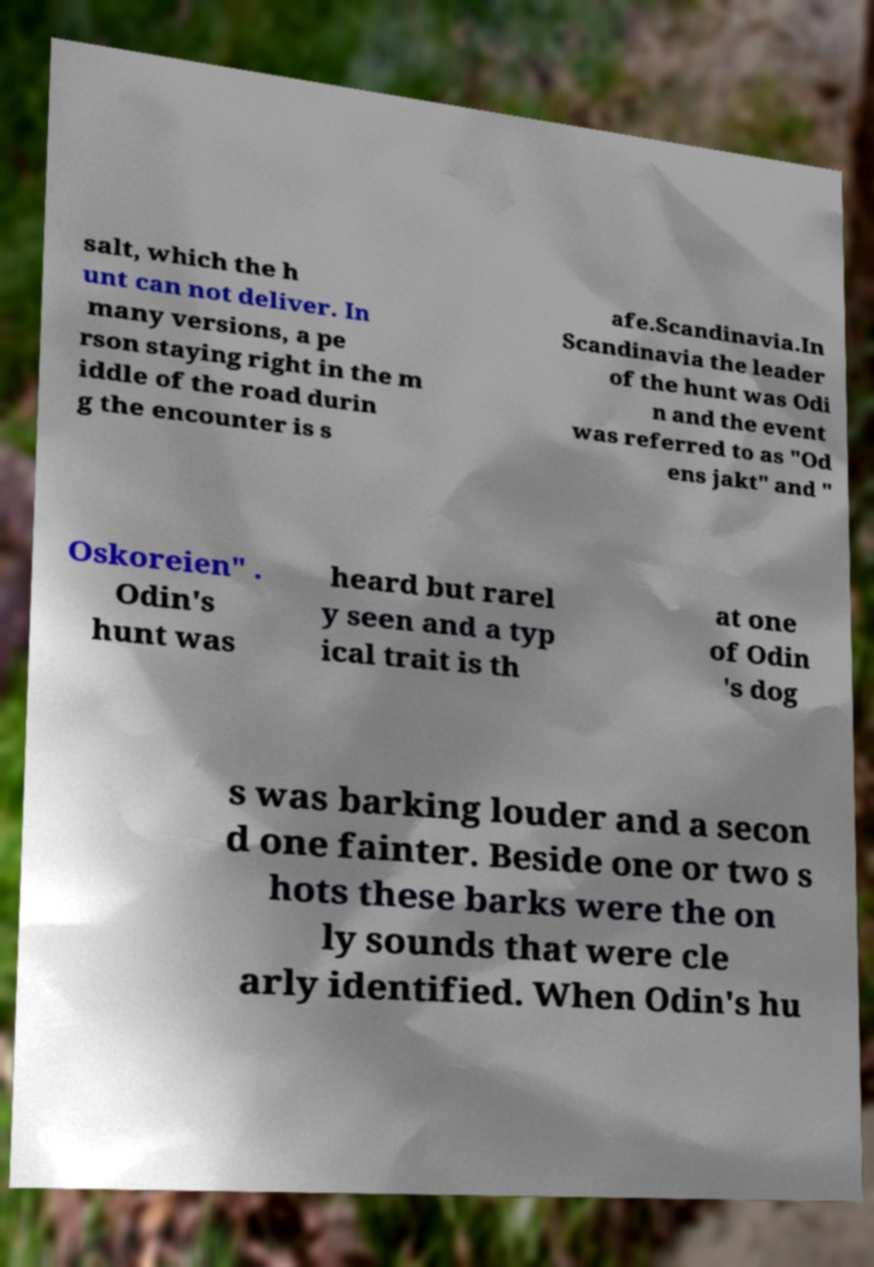I need the written content from this picture converted into text. Can you do that? salt, which the h unt can not deliver. In many versions, a pe rson staying right in the m iddle of the road durin g the encounter is s afe.Scandinavia.In Scandinavia the leader of the hunt was Odi n and the event was referred to as "Od ens jakt" and " Oskoreien" . Odin's hunt was heard but rarel y seen and a typ ical trait is th at one of Odin 's dog s was barking louder and a secon d one fainter. Beside one or two s hots these barks were the on ly sounds that were cle arly identified. When Odin's hu 